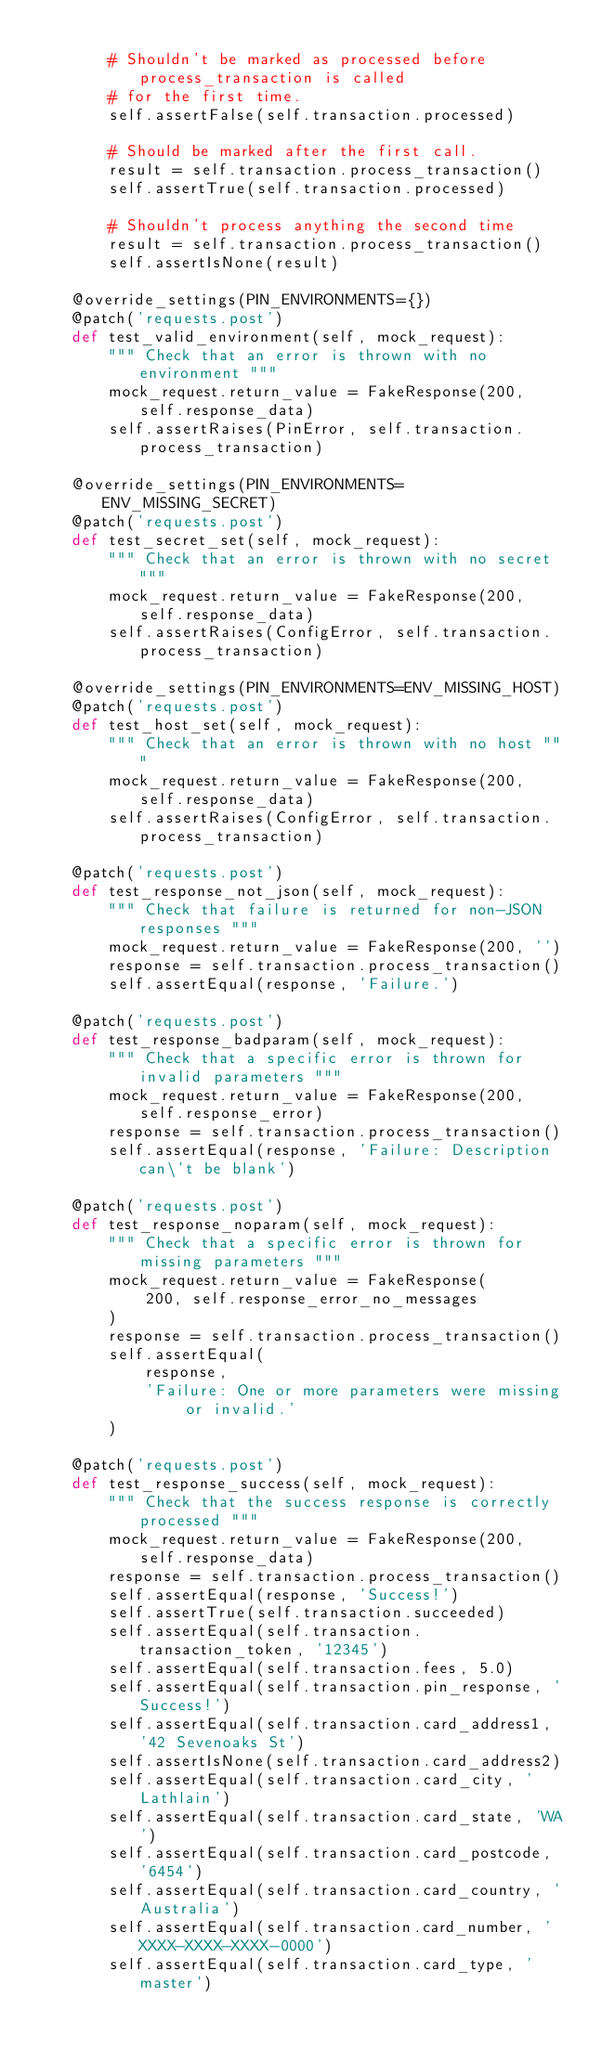<code> <loc_0><loc_0><loc_500><loc_500><_Python_>
        # Shouldn't be marked as processed before process_transaction is called
        # for the first time.
        self.assertFalse(self.transaction.processed)

        # Should be marked after the first call.
        result = self.transaction.process_transaction()
        self.assertTrue(self.transaction.processed)

        # Shouldn't process anything the second time
        result = self.transaction.process_transaction()
        self.assertIsNone(result)

    @override_settings(PIN_ENVIRONMENTS={})
    @patch('requests.post')
    def test_valid_environment(self, mock_request):
        """ Check that an error is thrown with no environment """
        mock_request.return_value = FakeResponse(200, self.response_data)
        self.assertRaises(PinError, self.transaction.process_transaction)

    @override_settings(PIN_ENVIRONMENTS=ENV_MISSING_SECRET)
    @patch('requests.post')
    def test_secret_set(self, mock_request):
        """ Check that an error is thrown with no secret """
        mock_request.return_value = FakeResponse(200, self.response_data)
        self.assertRaises(ConfigError, self.transaction.process_transaction)

    @override_settings(PIN_ENVIRONMENTS=ENV_MISSING_HOST)
    @patch('requests.post')
    def test_host_set(self, mock_request):
        """ Check that an error is thrown with no host """
        mock_request.return_value = FakeResponse(200, self.response_data)
        self.assertRaises(ConfigError, self.transaction.process_transaction)

    @patch('requests.post')
    def test_response_not_json(self, mock_request):
        """ Check that failure is returned for non-JSON responses """
        mock_request.return_value = FakeResponse(200, '')
        response = self.transaction.process_transaction()
        self.assertEqual(response, 'Failure.')

    @patch('requests.post')
    def test_response_badparam(self, mock_request):
        """ Check that a specific error is thrown for invalid parameters """
        mock_request.return_value = FakeResponse(200, self.response_error)
        response = self.transaction.process_transaction()
        self.assertEqual(response, 'Failure: Description can\'t be blank')

    @patch('requests.post')
    def test_response_noparam(self, mock_request):
        """ Check that a specific error is thrown for missing parameters """
        mock_request.return_value = FakeResponse(
            200, self.response_error_no_messages
        )
        response = self.transaction.process_transaction()
        self.assertEqual(
            response,
            'Failure: One or more parameters were missing or invalid.'
        )

    @patch('requests.post')
    def test_response_success(self, mock_request):
        """ Check that the success response is correctly processed """
        mock_request.return_value = FakeResponse(200, self.response_data)
        response = self.transaction.process_transaction()
        self.assertEqual(response, 'Success!')
        self.assertTrue(self.transaction.succeeded)
        self.assertEqual(self.transaction.transaction_token, '12345')
        self.assertEqual(self.transaction.fees, 5.0)
        self.assertEqual(self.transaction.pin_response, 'Success!')
        self.assertEqual(self.transaction.card_address1, '42 Sevenoaks St')
        self.assertIsNone(self.transaction.card_address2)
        self.assertEqual(self.transaction.card_city, 'Lathlain')
        self.assertEqual(self.transaction.card_state, 'WA')
        self.assertEqual(self.transaction.card_postcode, '6454')
        self.assertEqual(self.transaction.card_country, 'Australia')
        self.assertEqual(self.transaction.card_number, 'XXXX-XXXX-XXXX-0000')
        self.assertEqual(self.transaction.card_type, 'master')
</code> 